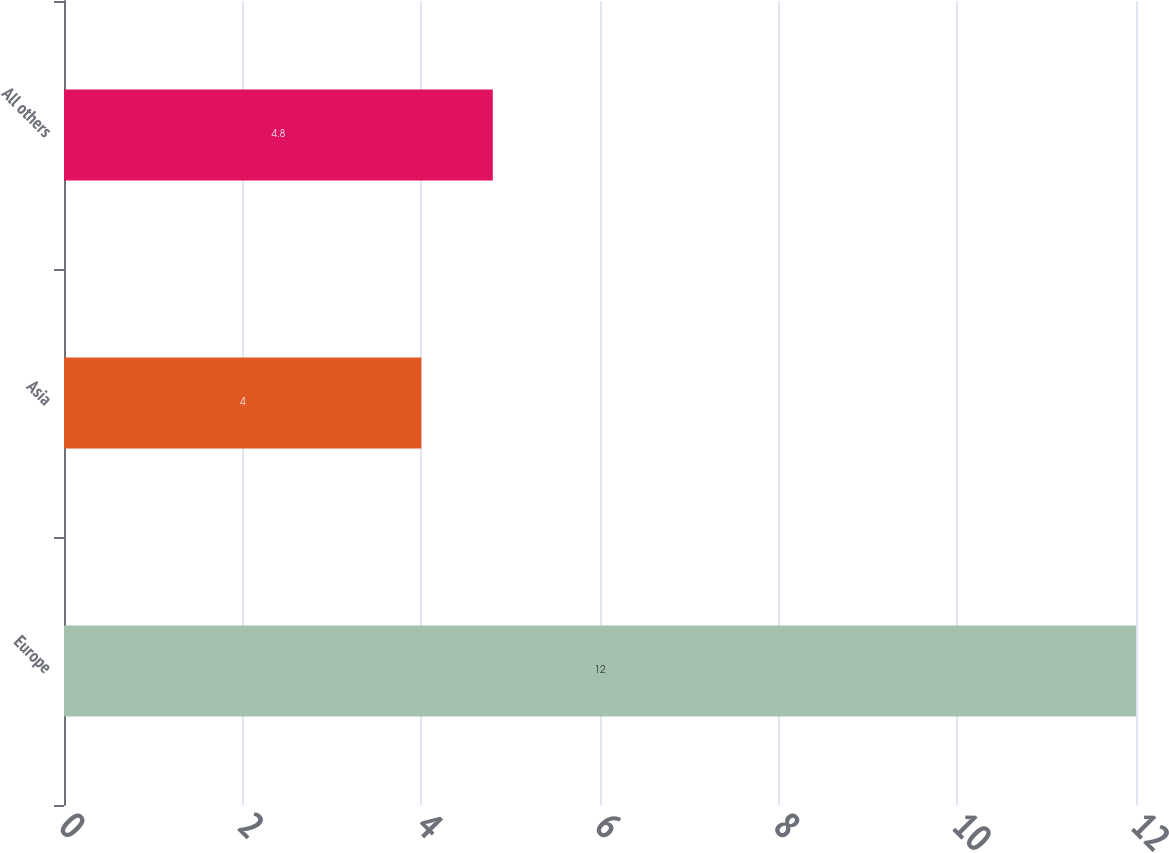Convert chart. <chart><loc_0><loc_0><loc_500><loc_500><bar_chart><fcel>Europe<fcel>Asia<fcel>All others<nl><fcel>12<fcel>4<fcel>4.8<nl></chart> 